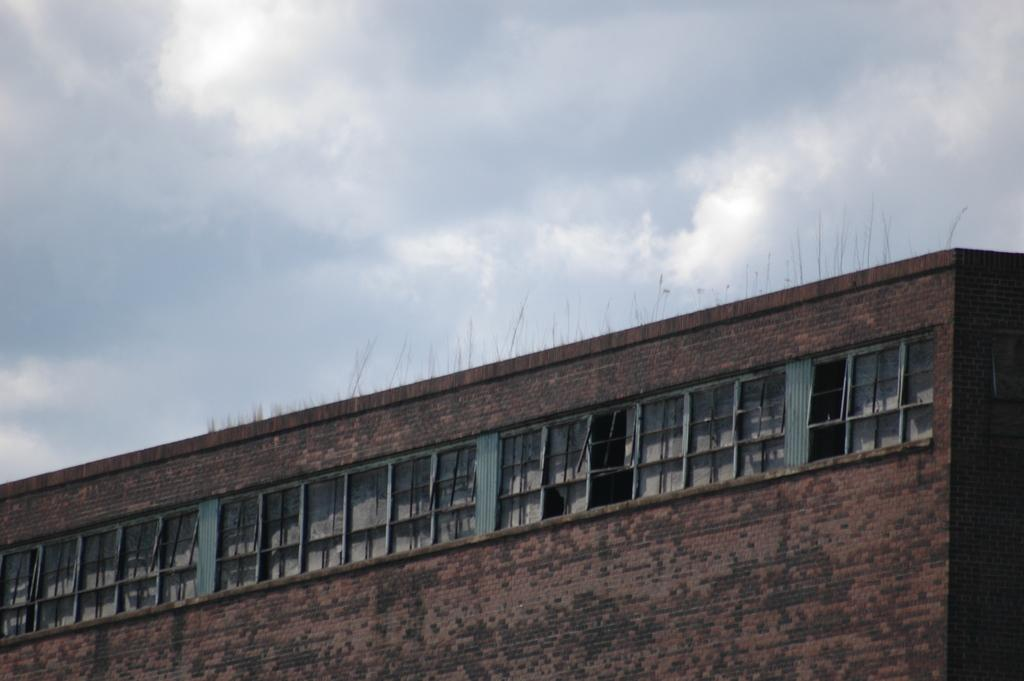What type of structure is present in the image? There is a building in the image. What colors are used for the building? The building is red and black in color. What material is the building made of? The building is made up of bricks. Are there any openings in the building? Yes, there are windows in the building. What can be seen in the background of the image? The sky is visible in the background of the image. How many cars are parked in front of the building in the image? There are no cars visible in the image; it only shows the building and the sky. What type of glue is used to hold the bricks together in the building? The image does not provide information about the type of glue used to hold the bricks together in the building. 